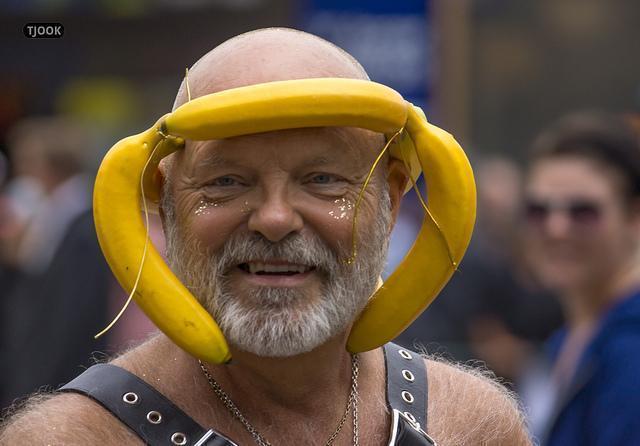If the man eats what is around his head what vitamin will he get?
Indicate the correct response and explain using: 'Answer: answer
Rationale: rationale.'
Options: Vitamin c, vitamin w, vitamin d, vitamin r. Answer: vitamin c.
Rationale: Bananas are known to contain vitamin c. 